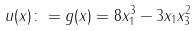<formula> <loc_0><loc_0><loc_500><loc_500>u ( x ) \colon = g ( x ) = 8 x _ { 1 } ^ { 3 } - 3 x _ { 1 } x _ { 3 } ^ { 2 }</formula> 